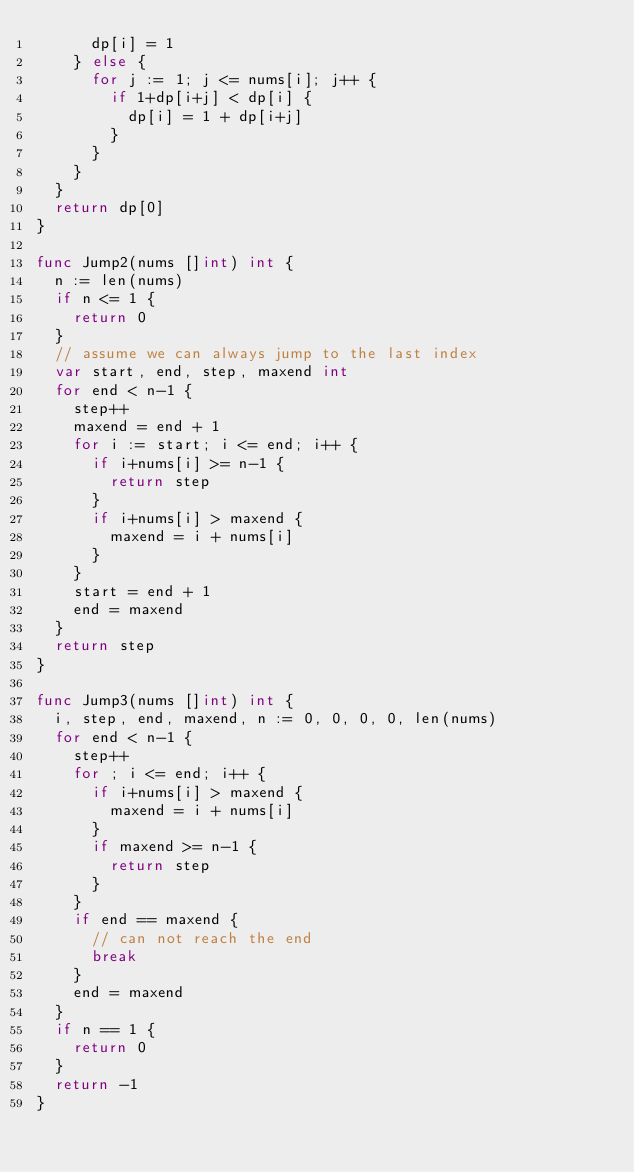<code> <loc_0><loc_0><loc_500><loc_500><_Go_>			dp[i] = 1
		} else {
			for j := 1; j <= nums[i]; j++ {
				if 1+dp[i+j] < dp[i] {
					dp[i] = 1 + dp[i+j]
				}
			}
		}
	}
	return dp[0]
}

func Jump2(nums []int) int {
	n := len(nums)
	if n <= 1 {
		return 0
	}
	// assume we can always jump to the last index
	var start, end, step, maxend int
	for end < n-1 {
		step++
		maxend = end + 1
		for i := start; i <= end; i++ {
			if i+nums[i] >= n-1 {
				return step
			}
			if i+nums[i] > maxend {
				maxend = i + nums[i]
			}
		}
		start = end + 1
		end = maxend
	}
	return step
}

func Jump3(nums []int) int {
	i, step, end, maxend, n := 0, 0, 0, 0, len(nums)
	for end < n-1 {
		step++
		for ; i <= end; i++ {
			if i+nums[i] > maxend {
				maxend = i + nums[i]
			}
			if maxend >= n-1 {
				return step
			}
		}
		if end == maxend {
			// can not reach the end
			break
		}
		end = maxend
	}
	if n == 1 {
		return 0
	}
	return -1
}
</code> 